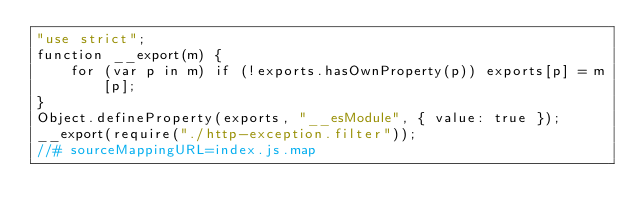Convert code to text. <code><loc_0><loc_0><loc_500><loc_500><_JavaScript_>"use strict";
function __export(m) {
    for (var p in m) if (!exports.hasOwnProperty(p)) exports[p] = m[p];
}
Object.defineProperty(exports, "__esModule", { value: true });
__export(require("./http-exception.filter"));
//# sourceMappingURL=index.js.map</code> 